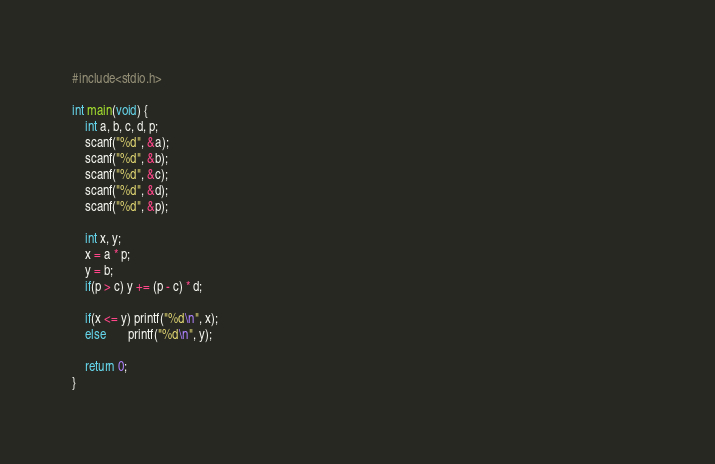<code> <loc_0><loc_0><loc_500><loc_500><_C_>#include<stdio.h>

int main(void) {
    int a, b, c, d, p;
    scanf("%d", &a);
    scanf("%d", &b);                                                                                                                                                     
    scanf("%d", &c);
    scanf("%d", &d);
    scanf("%d", &p);

    int x, y;
    x = a * p;
    y = b;
    if(p > c) y += (p - c) * d;

    if(x <= y) printf("%d\n", x); 
    else       printf("%d\n", y); 

    return 0;
}</code> 